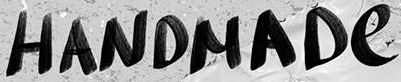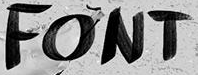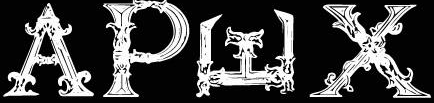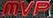What words can you see in these images in sequence, separated by a semicolon? HANDMADe; FONT; APWX; MVP 